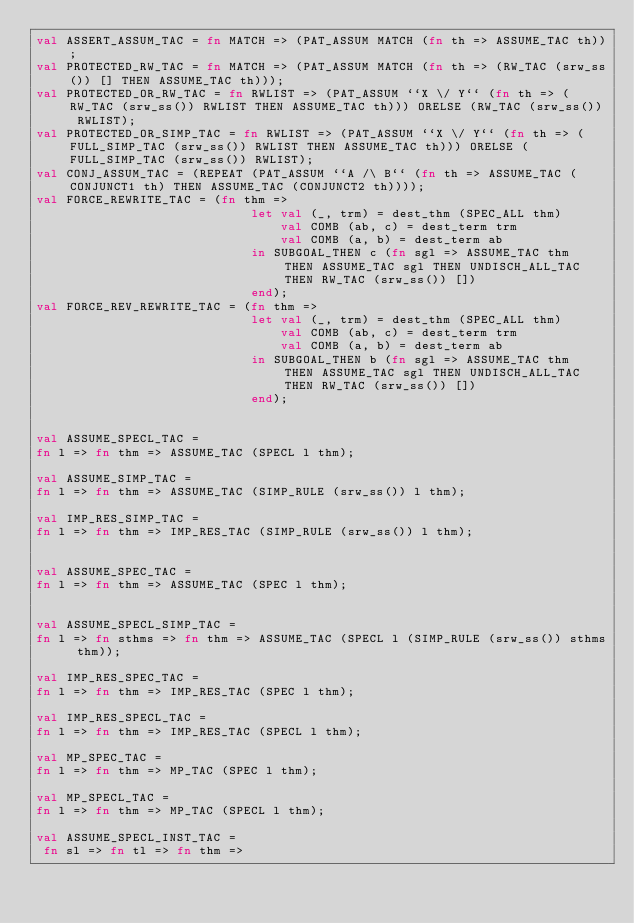Convert code to text. <code><loc_0><loc_0><loc_500><loc_500><_SML_>val ASSERT_ASSUM_TAC = fn MATCH => (PAT_ASSUM MATCH (fn th => ASSUME_TAC th));
val PROTECTED_RW_TAC = fn MATCH => (PAT_ASSUM MATCH (fn th => (RW_TAC (srw_ss()) [] THEN ASSUME_TAC th)));
val PROTECTED_OR_RW_TAC = fn RWLIST => (PAT_ASSUM ``X \/ Y`` (fn th => (RW_TAC (srw_ss()) RWLIST THEN ASSUME_TAC th))) ORELSE (RW_TAC (srw_ss()) RWLIST);
val PROTECTED_OR_SIMP_TAC = fn RWLIST => (PAT_ASSUM ``X \/ Y`` (fn th => (FULL_SIMP_TAC (srw_ss()) RWLIST THEN ASSUME_TAC th))) ORELSE (FULL_SIMP_TAC (srw_ss()) RWLIST);
val CONJ_ASSUM_TAC = (REPEAT (PAT_ASSUM ``A /\ B`` (fn th => ASSUME_TAC (CONJUNCT1 th) THEN ASSUME_TAC (CONJUNCT2 th))));
val FORCE_REWRITE_TAC = (fn thm =>
                             let val (_, trm) = dest_thm (SPEC_ALL thm)
                                 val COMB (ab, c) = dest_term trm
                                 val COMB (a, b) = dest_term ab
                             in SUBGOAL_THEN c (fn sgl => ASSUME_TAC thm  THEN ASSUME_TAC sgl THEN UNDISCH_ALL_TAC THEN RW_TAC (srw_ss()) [])
                             end);
val FORCE_REV_REWRITE_TAC = (fn thm =>
                             let val (_, trm) = dest_thm (SPEC_ALL thm)
                                 val COMB (ab, c) = dest_term trm
                                 val COMB (a, b) = dest_term ab
                             in SUBGOAL_THEN b (fn sgl => ASSUME_TAC thm  THEN ASSUME_TAC sgl THEN UNDISCH_ALL_TAC THEN RW_TAC (srw_ss()) [])
                             end);


val ASSUME_SPECL_TAC = 
fn l => fn thm => ASSUME_TAC (SPECL l thm);

val ASSUME_SIMP_TAC = 
fn l => fn thm => ASSUME_TAC (SIMP_RULE (srw_ss()) l thm);

val IMP_RES_SIMP_TAC = 
fn l => fn thm => IMP_RES_TAC (SIMP_RULE (srw_ss()) l thm);


val ASSUME_SPEC_TAC = 
fn l => fn thm => ASSUME_TAC (SPEC l thm);


val ASSUME_SPECL_SIMP_TAC = 
fn l => fn sthms => fn thm => ASSUME_TAC (SPECL l (SIMP_RULE (srw_ss()) sthms thm));

val IMP_RES_SPEC_TAC = 
fn l => fn thm => IMP_RES_TAC (SPEC l thm);

val IMP_RES_SPECL_TAC = 
fn l => fn thm => IMP_RES_TAC (SPECL l thm);

val MP_SPEC_TAC = 
fn l => fn thm => MP_TAC (SPEC l thm);

val MP_SPECL_TAC = 
fn l => fn thm => MP_TAC (SPECL l thm);

val ASSUME_SPECL_INST_TAC =  
 fn sl => fn tl => fn thm =></code> 